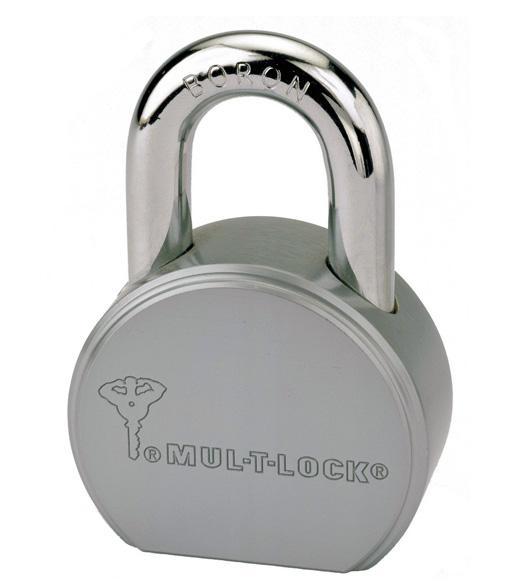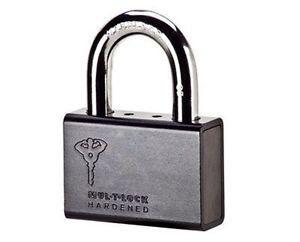The first image is the image on the left, the second image is the image on the right. Examine the images to the left and right. Is the description "there are locks with color other than silver" accurate? Answer yes or no. No. 